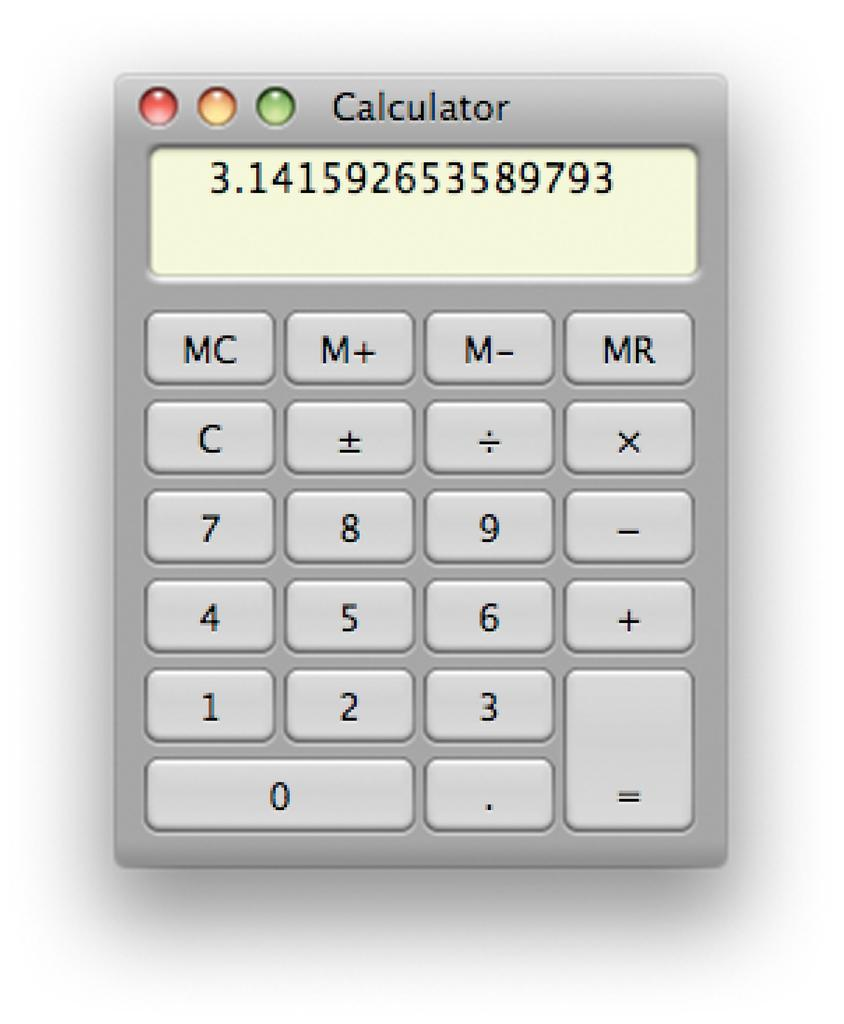<image>
Summarize the visual content of the image. A screenshot of a calculator program displays the number 3.141592653589793 